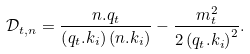<formula> <loc_0><loc_0><loc_500><loc_500>\mathcal { D } _ { t , n } = \frac { n . q _ { t } } { \left ( q _ { t } . k _ { i } \right ) \left ( n . k _ { i } \right ) } - \frac { m _ { t } ^ { 2 } } { 2 \left ( q _ { t } . k _ { i } \right ) ^ { 2 } } .</formula> 